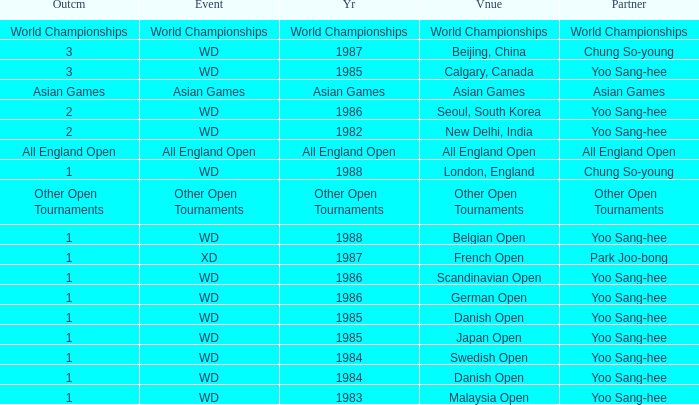What was the Outcome in 1983 of the WD Event? 1.0. 